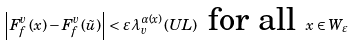Convert formula to latex. <formula><loc_0><loc_0><loc_500><loc_500>\, \left | F _ { f } ^ { v } \left ( x \right ) - F _ { f } ^ { v } \left ( \tilde { u } \right ) \right | < \varepsilon \lambda _ { v } ^ { \alpha \left ( x \right ) } \left ( U L \right ) \text { for all } x \in W _ { \varepsilon } \,</formula> 